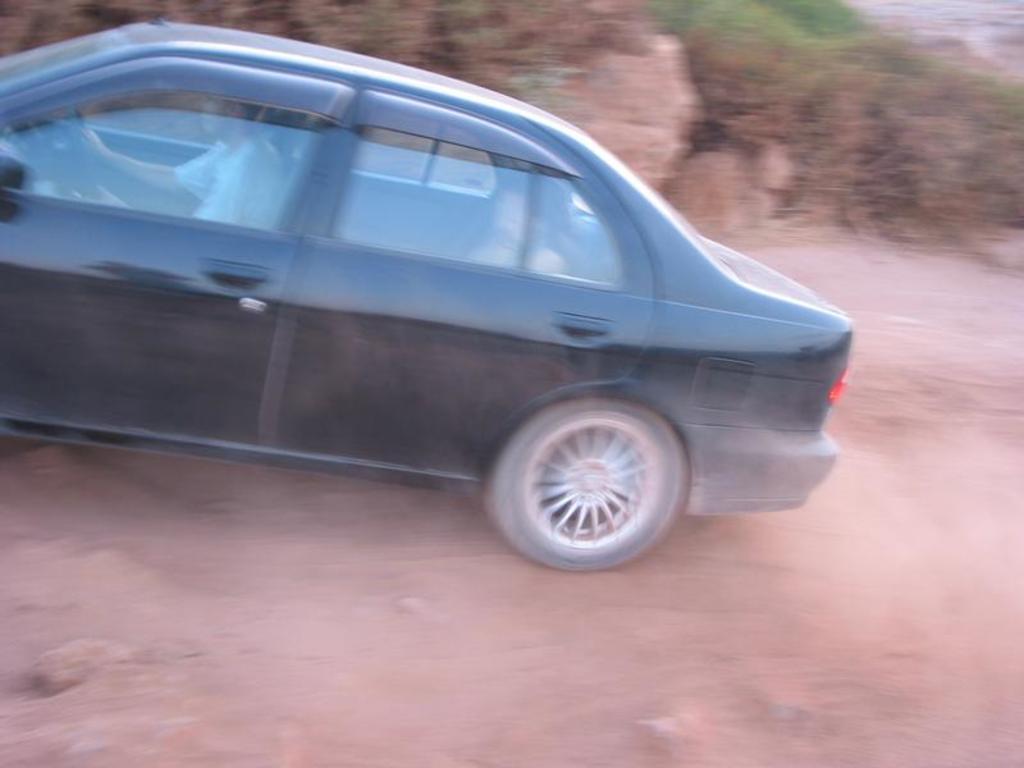Please provide a concise description of this image. In the center of the image we can see person in car on the road. In the background we can see trees and plants. 